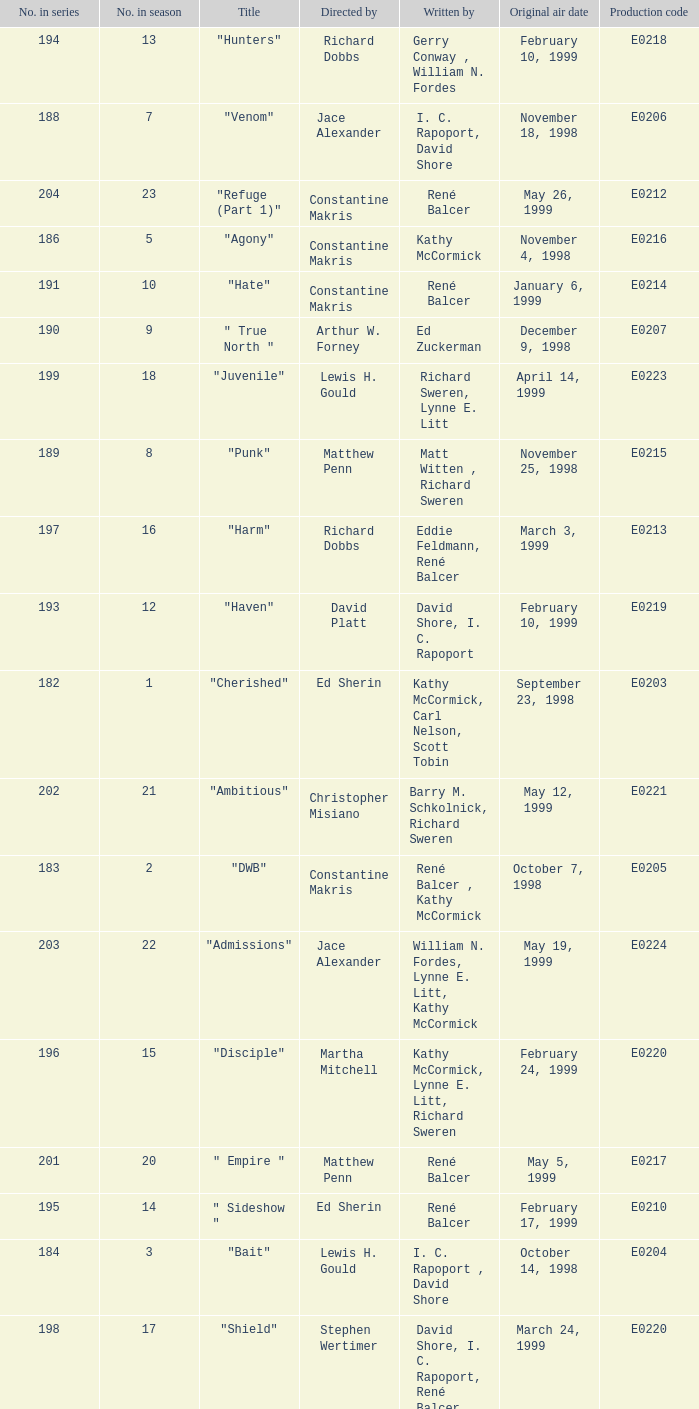What is the season number of the episode written by Matt Witten , Richard Sweren? 8.0. 